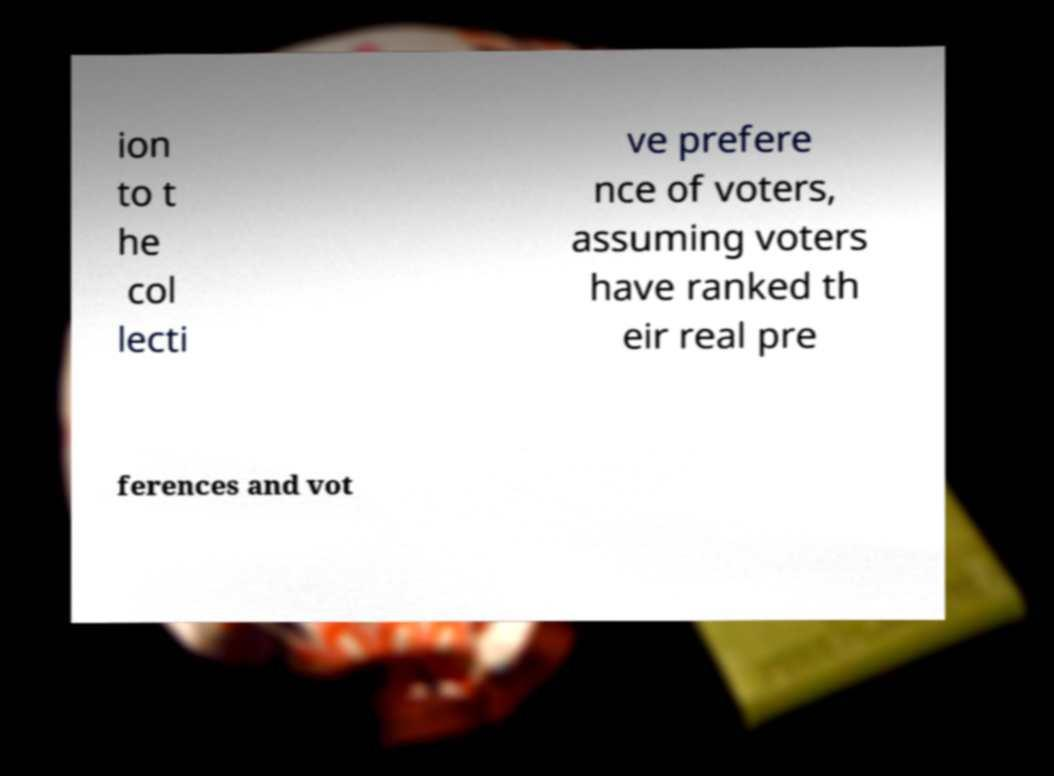Please identify and transcribe the text found in this image. ion to t he col lecti ve prefere nce of voters, assuming voters have ranked th eir real pre ferences and vot 